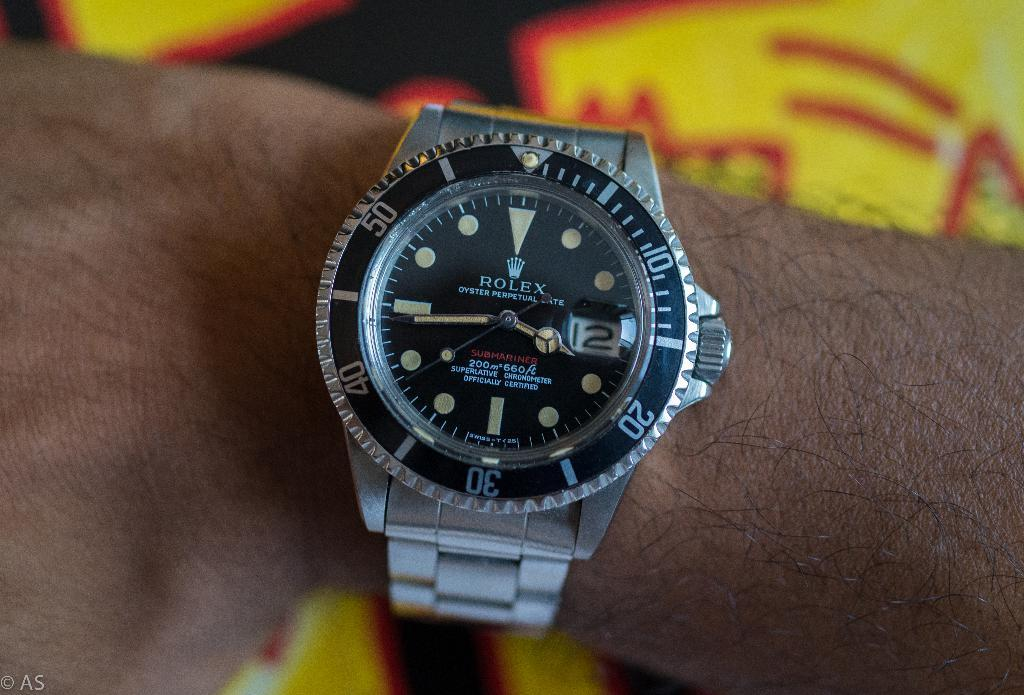<image>
Create a compact narrative representing the image presented. A man showing off his Rolex watch on his wrist. 